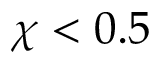<formula> <loc_0><loc_0><loc_500><loc_500>\chi < 0 . 5</formula> 